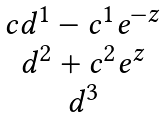<formula> <loc_0><loc_0><loc_500><loc_500>\begin{matrix} { c } d ^ { 1 } - c ^ { 1 } e ^ { - z } \\ d ^ { 2 } + c ^ { 2 } e ^ { z } \\ d ^ { 3 } \end{matrix}</formula> 